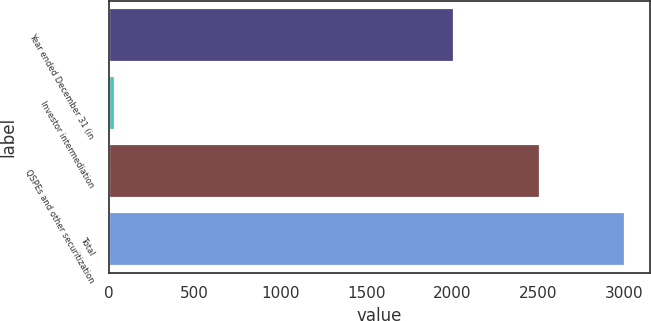Convert chart. <chart><loc_0><loc_0><loc_500><loc_500><bar_chart><fcel>Year ended December 31 (in<fcel>Investor intermediation<fcel>QSPEs and other securitization<fcel>Total<nl><fcel>2009<fcel>34<fcel>2510<fcel>3004<nl></chart> 